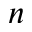Convert formula to latex. <formula><loc_0><loc_0><loc_500><loc_500>n</formula> 